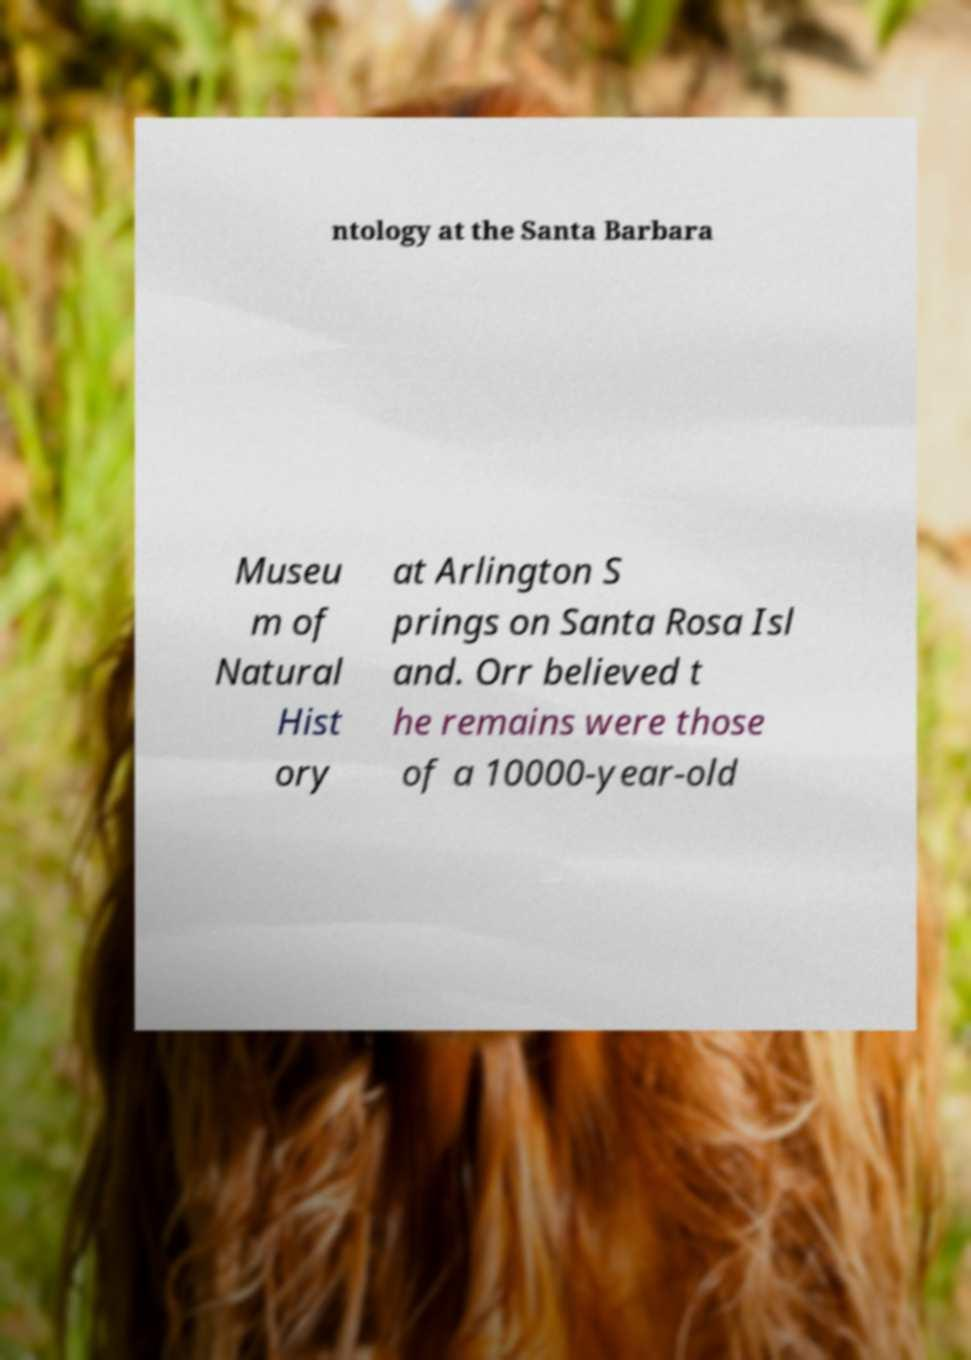There's text embedded in this image that I need extracted. Can you transcribe it verbatim? ntology at the Santa Barbara Museu m of Natural Hist ory at Arlington S prings on Santa Rosa Isl and. Orr believed t he remains were those of a 10000-year-old 